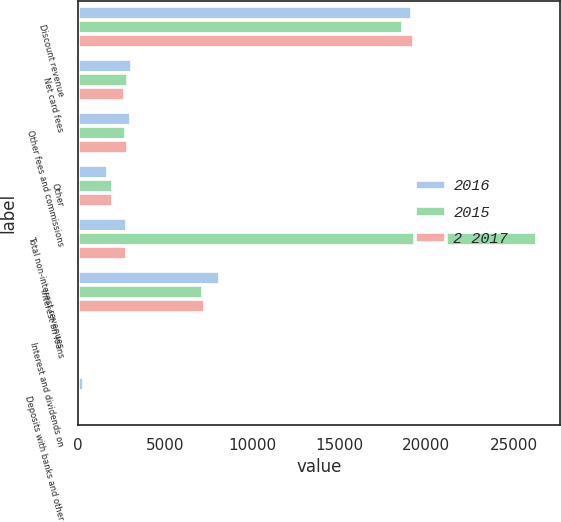<chart> <loc_0><loc_0><loc_500><loc_500><stacked_bar_chart><ecel><fcel>Discount revenue<fcel>Net card fees<fcel>Other fees and commissions<fcel>Other<fcel>Total non-interest revenues<fcel>Interest on loans<fcel>Interest and dividends on<fcel>Deposits with banks and other<nl><fcel>2016<fcel>19186<fcel>3090<fcel>3022<fcel>1732<fcel>2809.5<fcel>8138<fcel>89<fcel>326<nl><fcel>2015<fcel>18680<fcel>2886<fcel>2753<fcel>2029<fcel>26348<fcel>7205<fcel>131<fcel>139<nl><fcel>2 2017<fcel>19297<fcel>2700<fcel>2866<fcel>2033<fcel>2809.5<fcel>7309<fcel>157<fcel>79<nl></chart> 